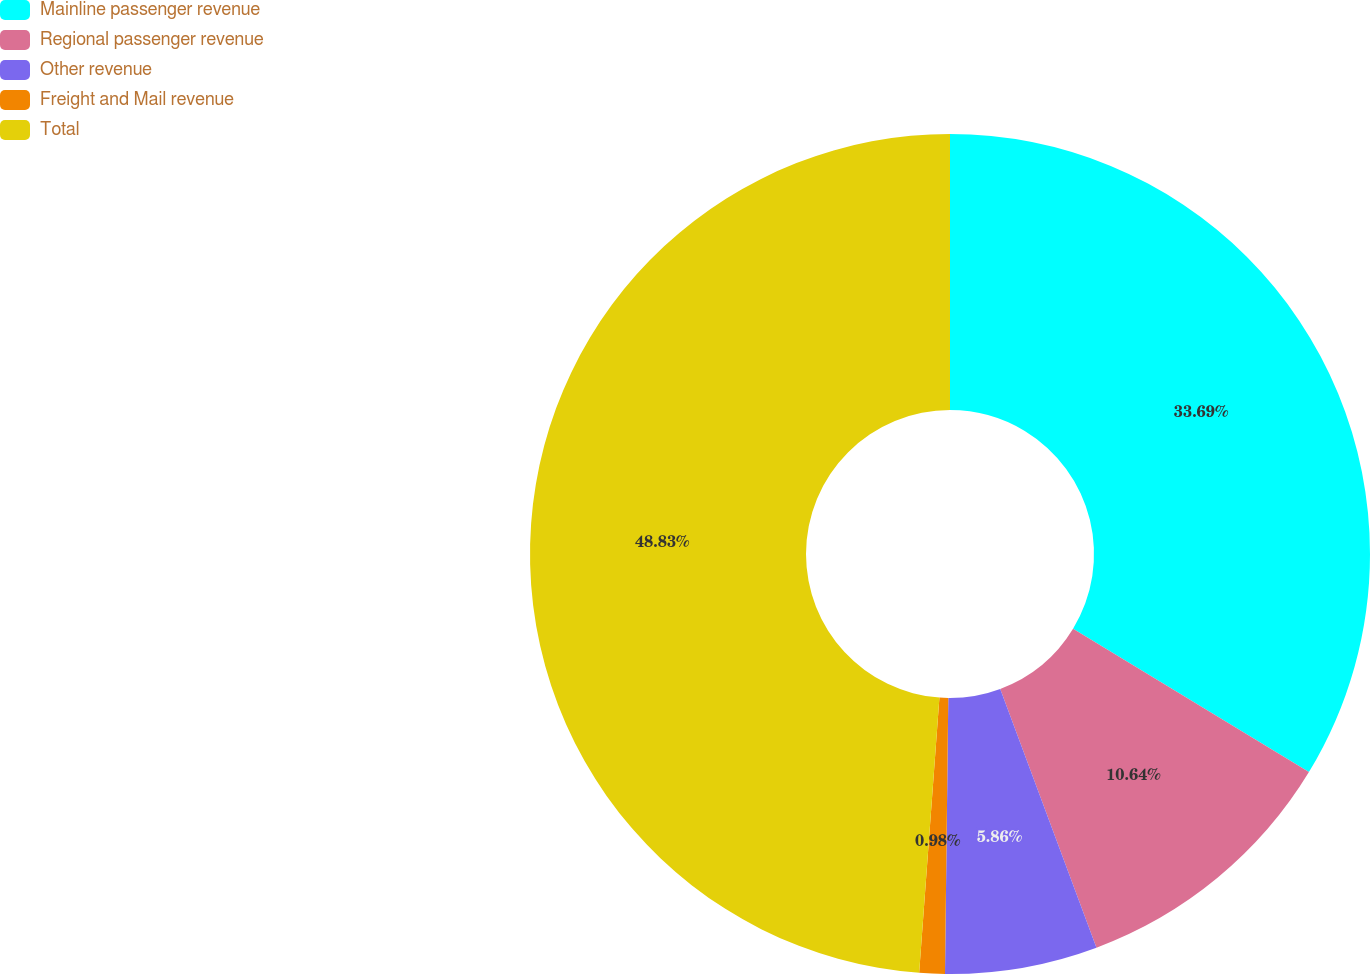Convert chart. <chart><loc_0><loc_0><loc_500><loc_500><pie_chart><fcel>Mainline passenger revenue<fcel>Regional passenger revenue<fcel>Other revenue<fcel>Freight and Mail revenue<fcel>Total<nl><fcel>33.69%<fcel>10.64%<fcel>5.86%<fcel>0.98%<fcel>48.83%<nl></chart> 